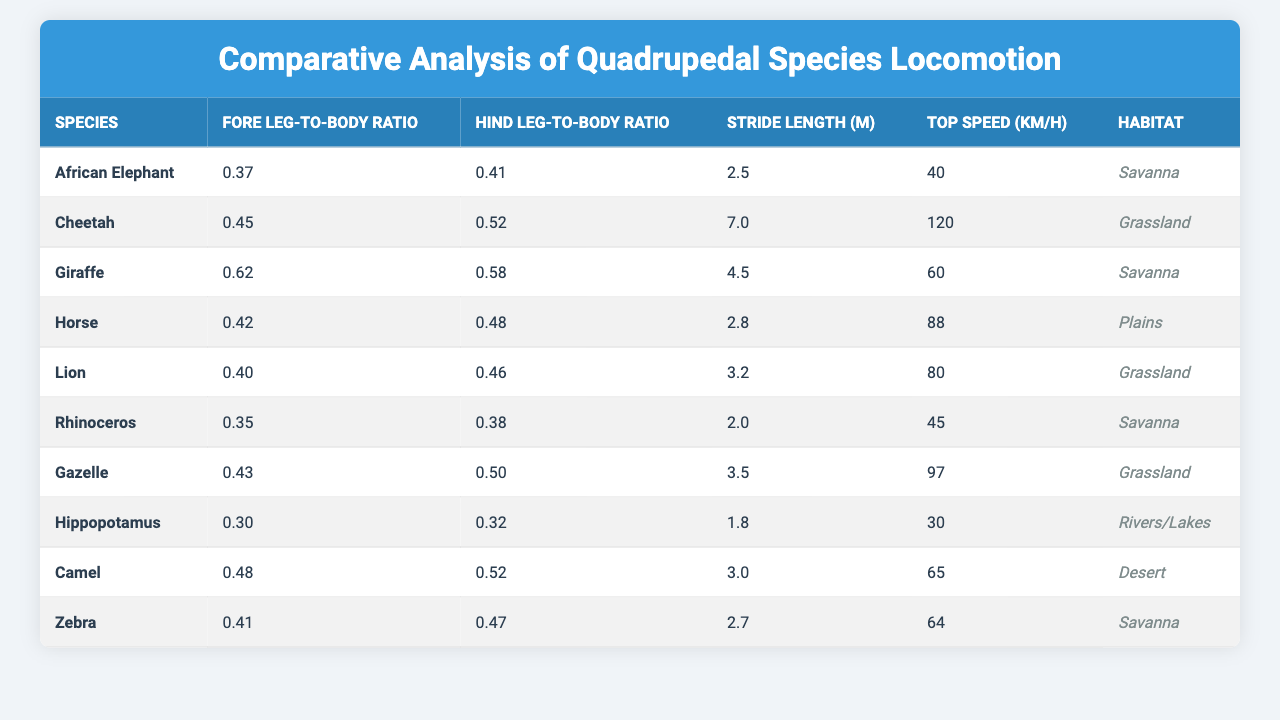What is the Fore Leg-to-Body Ratio of the Cheetah? The Cheetah's Fore Leg-to-Body Ratio is given directly in the table as 0.45.
Answer: 0.45 What habitat does the African Elephant reside in? The table lists the habitat of the African Elephant as Savanna.
Answer: Savanna Which species has the highest Top Speed? By examining the Top Speed values, the Cheetah has the highest speed at 120 km/h.
Answer: Cheetah What is the difference between the Hind Leg-to-Body Ratios of the Horse and the Lion? The Hind Leg-to-Body Ratio of the Horse is 0.48 and that of the Lion is 0.46. The difference is 0.48 - 0.46 = 0.02.
Answer: 0.02 Is the Giraffe faster than the Hippopotamus? The Giraffe has a Top Speed of 60 km/h while the Hippopotamus has a Top Speed of 30 km/h, confirming that the Giraffe is faster.
Answer: Yes What is the average Fore Leg-to-Body Ratio of all the species listed in the table? The Fore Leg-to-Body Ratios are 0.37, 0.45, 0.62, 0.42, 0.40, 0.35, 0.43, 0.30, 0.48, and 0.41. Adding them gives 4.13, and dividing by 10 gives an average of 0.413.
Answer: 0.413 Which species has the highest ratio between its Fore Leg-to-Body Ratio and its Top Speed? To find this ratio, calculate the Fore Leg-to-Body Ratio divided by the Top Speed for each species. The Cheetah's ratio is 0.45/120, which is approximately 0.00375, and other species will yield lower ratios. Thus, the Cheetah has the highest.
Answer: Cheetah Are both the Camel's leg-to-body ratios higher than those of the Hippopotamus? The Camel has a Fore Leg-to-Body Ratio of 0.48 and a Hind Leg-to-Body Ratio of 0.52, while the Hippopotamus has 0.30 and 0.32 respectively. Since both are higher, the answer is yes.
Answer: Yes What species has the lowest Hind Leg-to-Body Ratio, and what is that value? By checking the Hind Leg-to-Body Ratios, the Hippopotamus has the lowest ratio at 0.32.
Answer: Hippopotamus, 0.32 Subtract the Top Speed of the Rhinoceros from that of the Gazelle. The Top Speed of the Rhinoceros is 45 km/h, and the Gazelle is 97 km/h. The difference is 97 - 45 = 52 km/h.
Answer: 52 km/h Which species has both leg-to-body ratios above 0.50? Looking at both the Fore Leg-to-Body Ratio and Hind Leg-to-Body Ratio in the table, the Cheetah and Camel both have ratios above 0.50.
Answer: Cheetah, Camel 